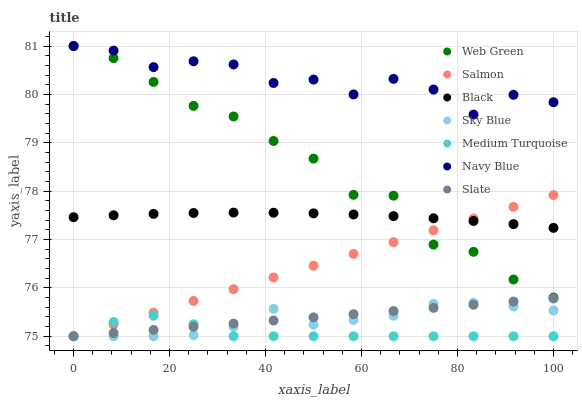Does Medium Turquoise have the minimum area under the curve?
Answer yes or no. Yes. Does Navy Blue have the maximum area under the curve?
Answer yes or no. Yes. Does Slate have the minimum area under the curve?
Answer yes or no. No. Does Slate have the maximum area under the curve?
Answer yes or no. No. Is Slate the smoothest?
Answer yes or no. Yes. Is Navy Blue the roughest?
Answer yes or no. Yes. Is Salmon the smoothest?
Answer yes or no. No. Is Salmon the roughest?
Answer yes or no. No. Does Slate have the lowest value?
Answer yes or no. Yes. Does Web Green have the lowest value?
Answer yes or no. No. Does Web Green have the highest value?
Answer yes or no. Yes. Does Slate have the highest value?
Answer yes or no. No. Is Medium Turquoise less than Black?
Answer yes or no. Yes. Is Black greater than Slate?
Answer yes or no. Yes. Does Medium Turquoise intersect Sky Blue?
Answer yes or no. Yes. Is Medium Turquoise less than Sky Blue?
Answer yes or no. No. Is Medium Turquoise greater than Sky Blue?
Answer yes or no. No. Does Medium Turquoise intersect Black?
Answer yes or no. No. 